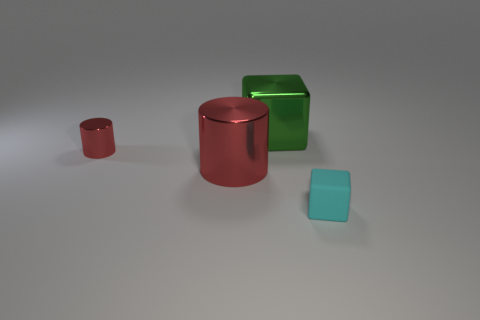Are there any shiny things that have the same size as the cyan matte thing?
Keep it short and to the point. Yes. What number of matte objects are either big cylinders or big blocks?
Make the answer very short. 0. The other metallic thing that is the same color as the small metal object is what shape?
Offer a terse response. Cylinder. What number of green shiny things are there?
Your answer should be compact. 1. Is the material of the small object that is in front of the small red shiny cylinder the same as the red object that is in front of the small metal cylinder?
Keep it short and to the point. No. The green thing that is made of the same material as the big red thing is what size?
Ensure brevity in your answer.  Large. What shape is the small thing that is left of the matte thing?
Make the answer very short. Cylinder. There is a big object to the left of the big shiny cube; is its color the same as the thing behind the small metallic cylinder?
Offer a terse response. No. The other cylinder that is the same color as the large metal cylinder is what size?
Make the answer very short. Small. Are any tiny purple rubber blocks visible?
Provide a succinct answer. No. 